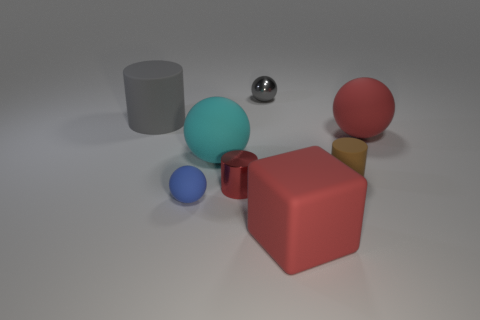What is the material of the big object that is the same color as the matte cube?
Your response must be concise. Rubber. How many other objects are the same color as the rubber block?
Provide a succinct answer. 2. There is a cyan thing that is the same shape as the tiny gray thing; what material is it?
Make the answer very short. Rubber. There is a big rubber thing that is on the left side of the small blue matte object; is it the same color as the metal object that is behind the large red matte ball?
Provide a succinct answer. Yes. What is the shape of the small thing to the right of the tiny gray thing?
Keep it short and to the point. Cylinder. What color is the small matte cylinder?
Your answer should be very brief. Brown. What shape is the blue object that is the same material as the large gray thing?
Keep it short and to the point. Sphere. Do the red ball behind the red metal thing and the small gray ball have the same size?
Give a very brief answer. No. What number of things are cylinders in front of the large cyan rubber object or things in front of the small gray shiny thing?
Provide a succinct answer. 7. Do the cube in front of the large cyan ball and the tiny metal ball have the same color?
Offer a terse response. No. 